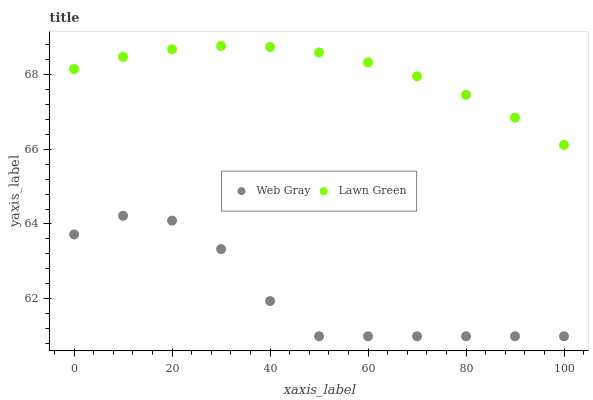Does Web Gray have the minimum area under the curve?
Answer yes or no. Yes. Does Lawn Green have the maximum area under the curve?
Answer yes or no. Yes. Does Web Gray have the maximum area under the curve?
Answer yes or no. No. Is Lawn Green the smoothest?
Answer yes or no. Yes. Is Web Gray the roughest?
Answer yes or no. Yes. Is Web Gray the smoothest?
Answer yes or no. No. Does Web Gray have the lowest value?
Answer yes or no. Yes. Does Lawn Green have the highest value?
Answer yes or no. Yes. Does Web Gray have the highest value?
Answer yes or no. No. Is Web Gray less than Lawn Green?
Answer yes or no. Yes. Is Lawn Green greater than Web Gray?
Answer yes or no. Yes. Does Web Gray intersect Lawn Green?
Answer yes or no. No. 